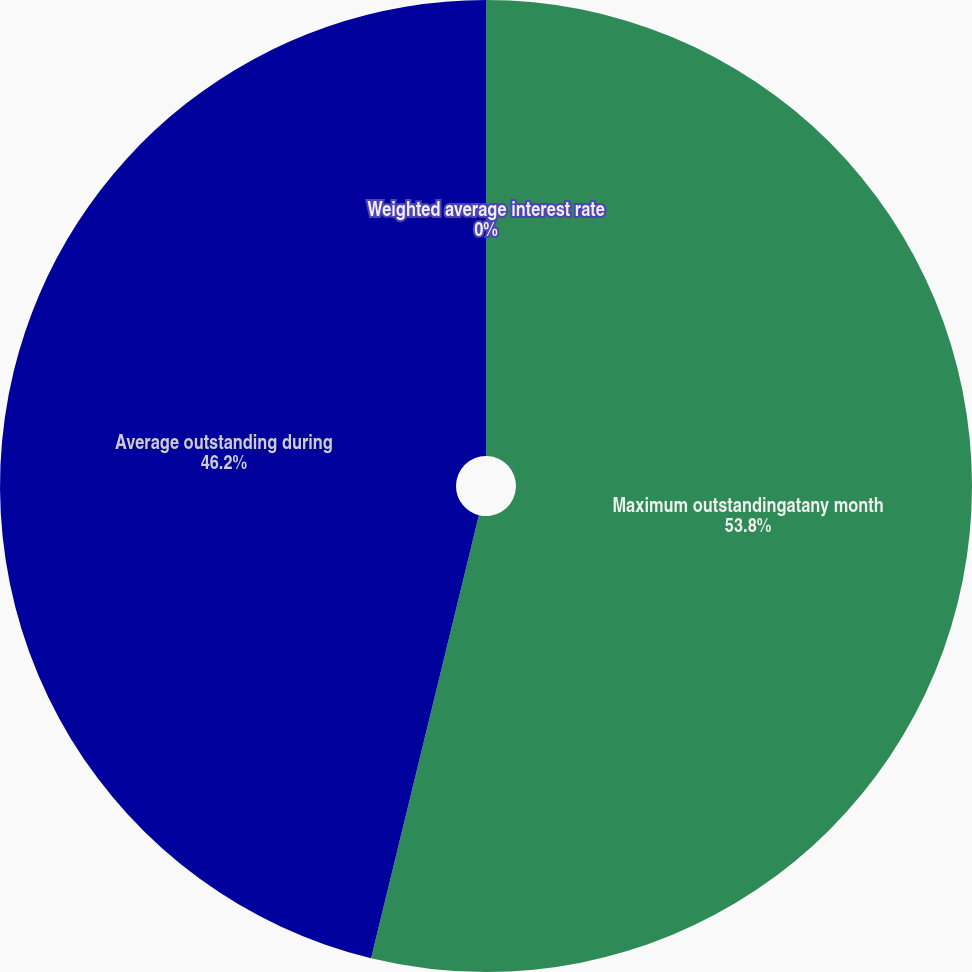Convert chart to OTSL. <chart><loc_0><loc_0><loc_500><loc_500><pie_chart><fcel>Maximum outstandingatany month<fcel>Average outstanding during<fcel>Weighted average interest rate<nl><fcel>53.8%<fcel>46.2%<fcel>0.0%<nl></chart> 